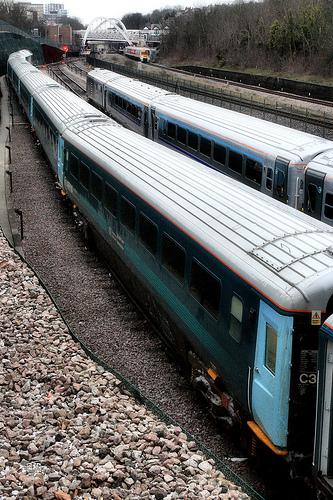Question: what color is the top of the trains?
Choices:
A. Grey.
B. Silver.
C. White.
D. Yellow.
Answer with the letter. Answer: B Question: where are the trains?
Choices:
A. On train tracks.
B. In the repair shop.
C. In the museum.
D. Off the tracks.
Answer with the letter. Answer: A Question: what is lining the train tracks?
Choices:
A. Woodchips.
B. Gravel.
C. Dirt.
D. Leaves.
Answer with the letter. Answer: B Question: how many trains are there?
Choices:
A. Three.
B. One.
C. Two.
D. Four.
Answer with the letter. Answer: A Question: what color are the trees?
Choices:
A. Yellow.
B. Red.
C. Green.
D. Brown.
Answer with the letter. Answer: C 